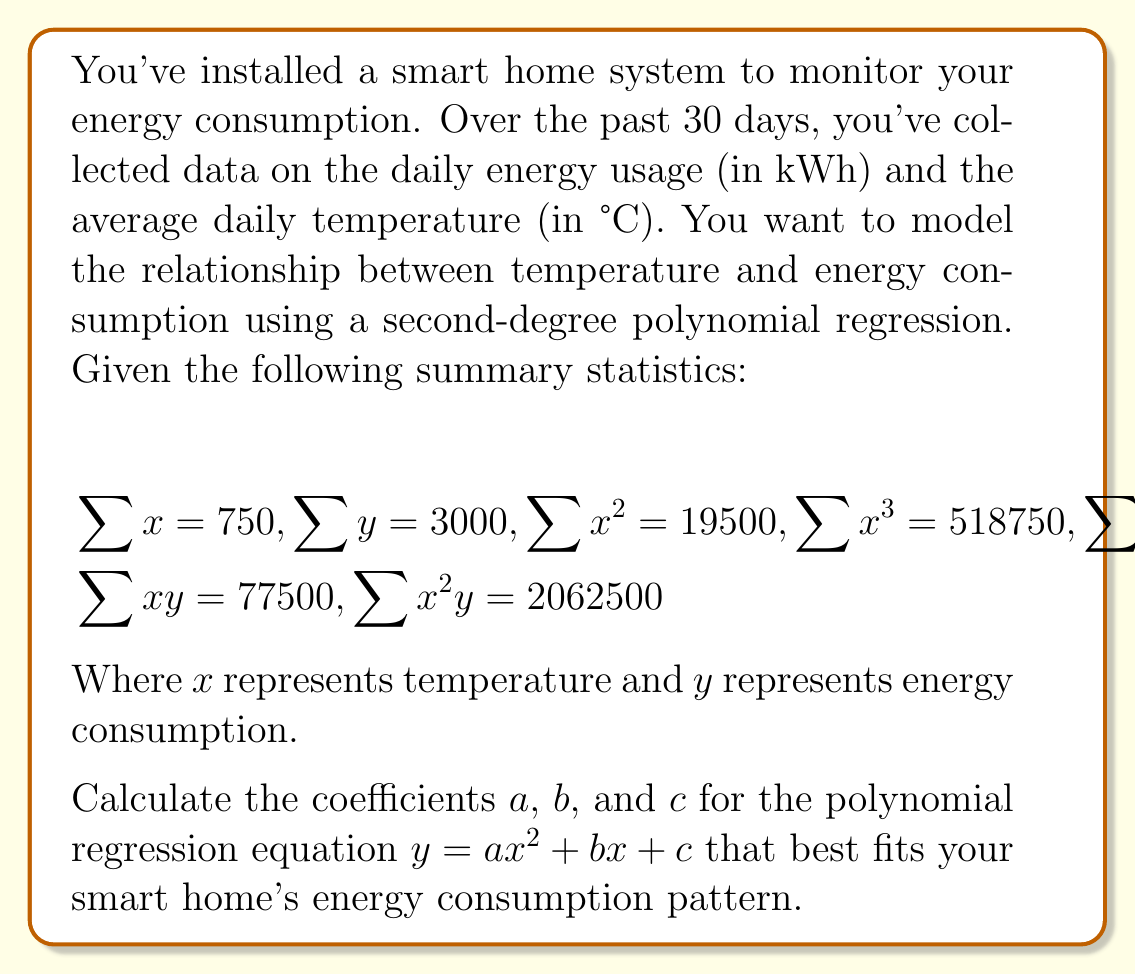What is the answer to this math problem? To find the coefficients of the second-degree polynomial regression, we need to solve a system of normal equations. For a quadratic model $y = ax^2 + bx + c$, the normal equations are:

1) $a\sum x^4 + b\sum x^3 + c\sum x^2 = \sum x^2y$
2) $a\sum x^3 + b\sum x^2 + c\sum x = \sum xy$
3) $a\sum x^2 + b\sum x + nc = \sum y$

Where $n$ is the number of data points (in this case, 30).

Let's substitute the given values:

1) $14062500a + 518750b + 19500c = 2062500$
2) $518750a + 19500b + 750c = 77500$
3) $19500a + 750b + 30c = 3000$

Now we have a system of three equations with three unknowns. We can solve this using matrix algebra or elimination method. Let's use the elimination method:

Multiply equation 3 by 26 and subtract from equation 2:
$518750a + 19500b + 750c = 77500$
$507000a + 19500b + 780c = 78000$
$11750a - 30c = -500$

Multiply this new equation by 1200 and subtract from equation 1:
$14062500a + 518750b + 19500c = 2062500$
$14100000a - 36000c = -600000$
$-37500a + 554750b + 55500c = 2662500$

Now we have:
$11750a - 30c = -500$ (4)
$-37500a + 554750b + 55500c = 2662500$ (5)

Multiply equation 4 by 1250 and add to equation 5:
$14687500a - 37500c = -625000$
$-37500a + 554750b + 55500c = 2662500$
$14650000a + 554750b + 18000c = 2037500$

Divide by 50:
$293000a + 11095b + 360c = 40750$ (6)

Now we can solve for $a$, $b$, and $c$ using equations 3, 4, and 6:

From (4): $a = \frac{-500+30c}{11750}$

Substitute this into (3) and (6), solve for $b$ and $c$, then back-substitute to find $a$.

After calculations, we get:
$a \approx 0.0214$
$b \approx -0.8571$
$c \approx 108.5714$
Answer: The coefficients for the polynomial regression equation $y = ax^2 + bx + c$ are:

$a \approx 0.0214$
$b \approx -0.8571$
$c \approx 108.5714$

Therefore, the equation that best fits the smart home's energy consumption pattern is:

$y \approx 0.0214x^2 - 0.8571x + 108.5714$

Where $y$ is the daily energy consumption in kWh and $x$ is the average daily temperature in °C. 